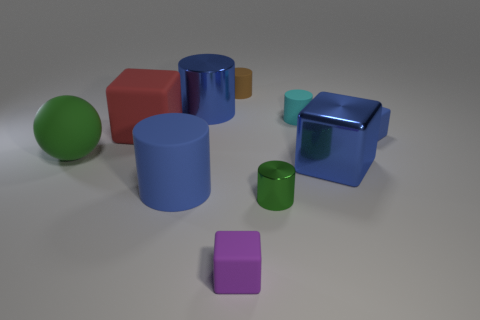What can you infer about the material of the objects? From the image, the objects seem to be made of a rubber-like material due to their matte finish and the way light reflects off of their surfaces. However, the larger blue cube appears to have a shinier surface, suggesting it might be made of plastic or a different type of rubber. 